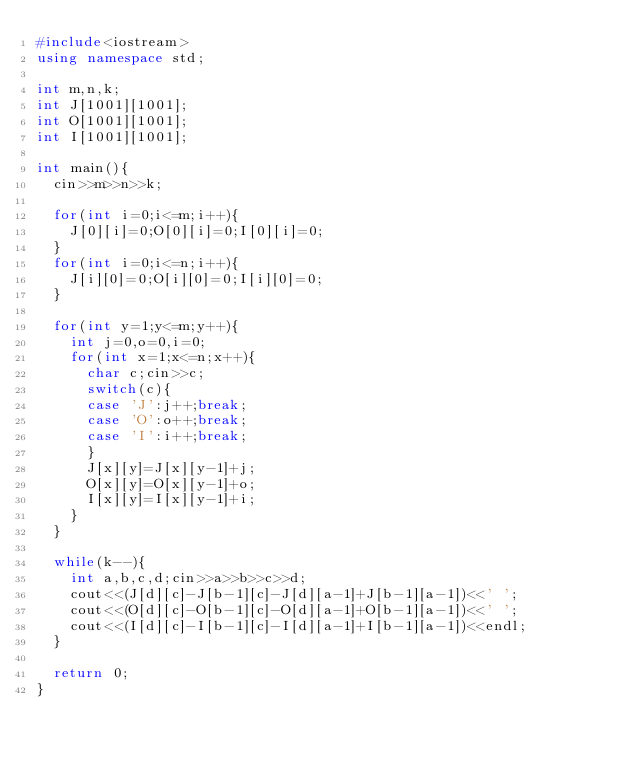<code> <loc_0><loc_0><loc_500><loc_500><_C++_>#include<iostream>
using namespace std;

int m,n,k;
int J[1001][1001];
int O[1001][1001];
int I[1001][1001];

int main(){
	cin>>m>>n>>k;
	
	for(int i=0;i<=m;i++){
		J[0][i]=0;O[0][i]=0;I[0][i]=0;
	}
	for(int i=0;i<=n;i++){
		J[i][0]=0;O[i][0]=0;I[i][0]=0;
	}
	
	for(int y=1;y<=m;y++){
		int j=0,o=0,i=0;
		for(int x=1;x<=n;x++){
			char c;cin>>c;
			switch(c){
			case 'J':j++;break;
			case 'O':o++;break;
			case 'I':i++;break;
			}
			J[x][y]=J[x][y-1]+j;
			O[x][y]=O[x][y-1]+o;
			I[x][y]=I[x][y-1]+i;
		}
	}
	
	while(k--){
		int a,b,c,d;cin>>a>>b>>c>>d;
		cout<<(J[d][c]-J[b-1][c]-J[d][a-1]+J[b-1][a-1])<<' ';
		cout<<(O[d][c]-O[b-1][c]-O[d][a-1]+O[b-1][a-1])<<' ';
		cout<<(I[d][c]-I[b-1][c]-I[d][a-1]+I[b-1][a-1])<<endl;
	}
	
	return 0;
}</code> 